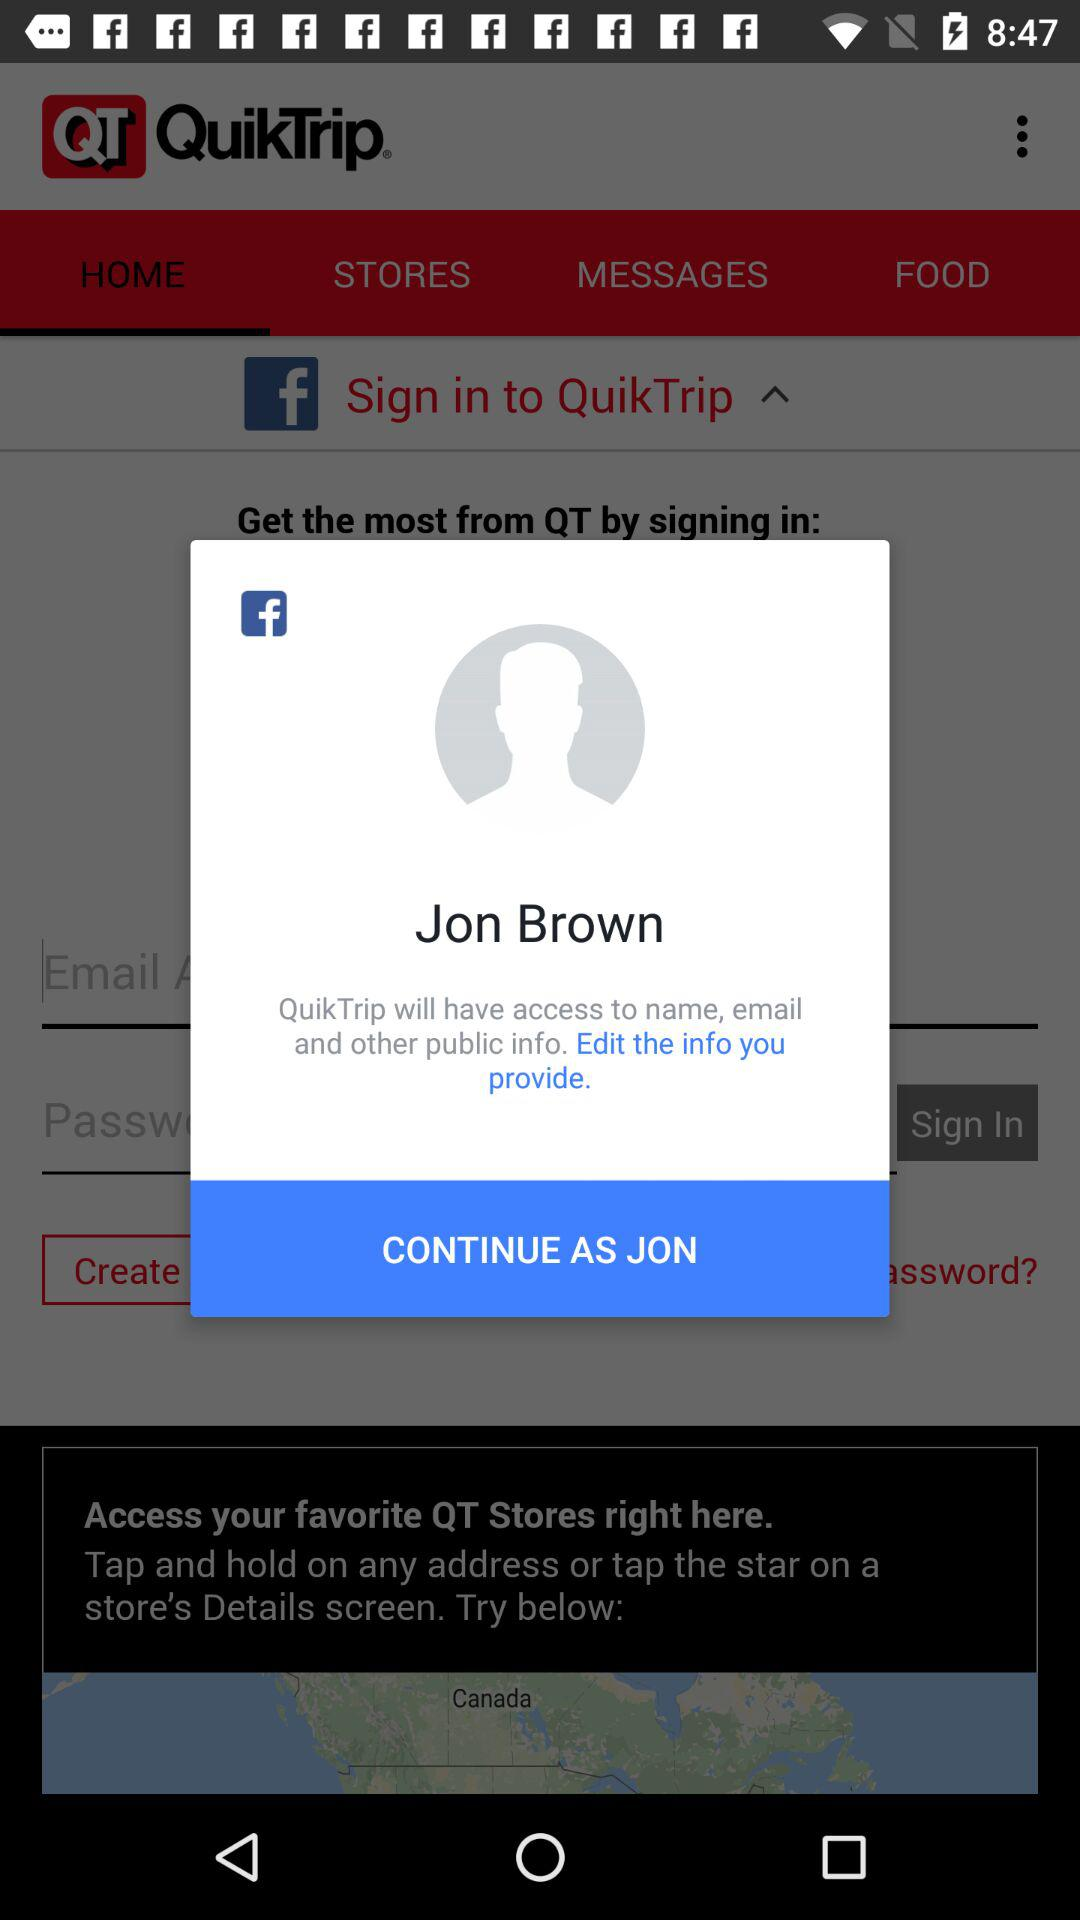What's the user's profile name? The user's profile name is Jon Brown. 